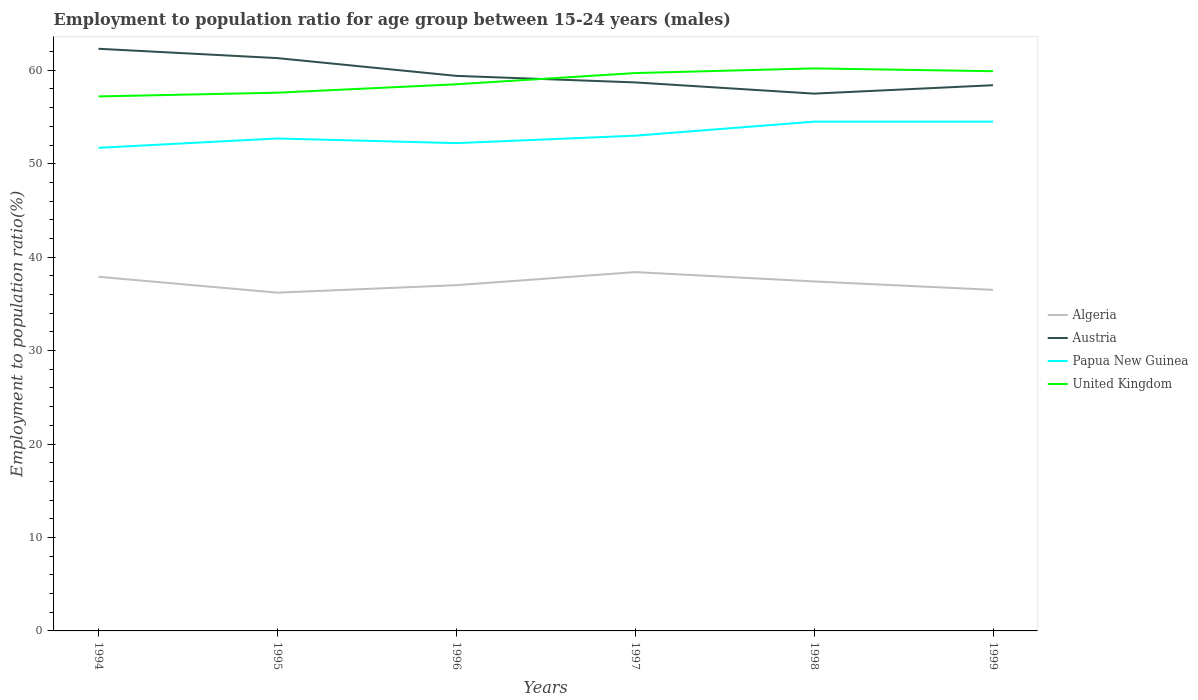How many different coloured lines are there?
Provide a short and direct response. 4. Is the number of lines equal to the number of legend labels?
Keep it short and to the point. Yes. Across all years, what is the maximum employment to population ratio in Papua New Guinea?
Ensure brevity in your answer.  51.7. What is the total employment to population ratio in Papua New Guinea in the graph?
Provide a succinct answer. -2.8. What is the difference between the highest and the second highest employment to population ratio in United Kingdom?
Make the answer very short. 3. Where does the legend appear in the graph?
Keep it short and to the point. Center right. How many legend labels are there?
Offer a terse response. 4. What is the title of the graph?
Provide a short and direct response. Employment to population ratio for age group between 15-24 years (males). Does "Upper middle income" appear as one of the legend labels in the graph?
Make the answer very short. No. What is the label or title of the Y-axis?
Give a very brief answer. Employment to population ratio(%). What is the Employment to population ratio(%) of Algeria in 1994?
Give a very brief answer. 37.9. What is the Employment to population ratio(%) in Austria in 1994?
Ensure brevity in your answer.  62.3. What is the Employment to population ratio(%) in Papua New Guinea in 1994?
Ensure brevity in your answer.  51.7. What is the Employment to population ratio(%) of United Kingdom in 1994?
Your response must be concise. 57.2. What is the Employment to population ratio(%) in Algeria in 1995?
Your answer should be very brief. 36.2. What is the Employment to population ratio(%) in Austria in 1995?
Offer a terse response. 61.3. What is the Employment to population ratio(%) in Papua New Guinea in 1995?
Give a very brief answer. 52.7. What is the Employment to population ratio(%) of United Kingdom in 1995?
Your response must be concise. 57.6. What is the Employment to population ratio(%) of Austria in 1996?
Keep it short and to the point. 59.4. What is the Employment to population ratio(%) in Papua New Guinea in 1996?
Offer a very short reply. 52.2. What is the Employment to population ratio(%) of United Kingdom in 1996?
Offer a terse response. 58.5. What is the Employment to population ratio(%) of Algeria in 1997?
Offer a very short reply. 38.4. What is the Employment to population ratio(%) of Austria in 1997?
Ensure brevity in your answer.  58.7. What is the Employment to population ratio(%) in Papua New Guinea in 1997?
Offer a terse response. 53. What is the Employment to population ratio(%) of United Kingdom in 1997?
Make the answer very short. 59.7. What is the Employment to population ratio(%) of Algeria in 1998?
Keep it short and to the point. 37.4. What is the Employment to population ratio(%) in Austria in 1998?
Provide a short and direct response. 57.5. What is the Employment to population ratio(%) in Papua New Guinea in 1998?
Your answer should be very brief. 54.5. What is the Employment to population ratio(%) in United Kingdom in 1998?
Your response must be concise. 60.2. What is the Employment to population ratio(%) in Algeria in 1999?
Offer a very short reply. 36.5. What is the Employment to population ratio(%) of Austria in 1999?
Make the answer very short. 58.4. What is the Employment to population ratio(%) of Papua New Guinea in 1999?
Provide a short and direct response. 54.5. What is the Employment to population ratio(%) of United Kingdom in 1999?
Make the answer very short. 59.9. Across all years, what is the maximum Employment to population ratio(%) in Algeria?
Make the answer very short. 38.4. Across all years, what is the maximum Employment to population ratio(%) in Austria?
Your answer should be compact. 62.3. Across all years, what is the maximum Employment to population ratio(%) in Papua New Guinea?
Ensure brevity in your answer.  54.5. Across all years, what is the maximum Employment to population ratio(%) of United Kingdom?
Your answer should be compact. 60.2. Across all years, what is the minimum Employment to population ratio(%) in Algeria?
Offer a very short reply. 36.2. Across all years, what is the minimum Employment to population ratio(%) of Austria?
Provide a succinct answer. 57.5. Across all years, what is the minimum Employment to population ratio(%) in Papua New Guinea?
Offer a terse response. 51.7. Across all years, what is the minimum Employment to population ratio(%) in United Kingdom?
Make the answer very short. 57.2. What is the total Employment to population ratio(%) of Algeria in the graph?
Your answer should be compact. 223.4. What is the total Employment to population ratio(%) of Austria in the graph?
Your response must be concise. 357.6. What is the total Employment to population ratio(%) in Papua New Guinea in the graph?
Give a very brief answer. 318.6. What is the total Employment to population ratio(%) of United Kingdom in the graph?
Offer a very short reply. 353.1. What is the difference between the Employment to population ratio(%) in Algeria in 1994 and that in 1995?
Provide a short and direct response. 1.7. What is the difference between the Employment to population ratio(%) of United Kingdom in 1994 and that in 1995?
Your answer should be very brief. -0.4. What is the difference between the Employment to population ratio(%) of Algeria in 1994 and that in 1996?
Ensure brevity in your answer.  0.9. What is the difference between the Employment to population ratio(%) in Austria in 1994 and that in 1996?
Offer a very short reply. 2.9. What is the difference between the Employment to population ratio(%) of United Kingdom in 1994 and that in 1996?
Provide a short and direct response. -1.3. What is the difference between the Employment to population ratio(%) of Algeria in 1994 and that in 1997?
Ensure brevity in your answer.  -0.5. What is the difference between the Employment to population ratio(%) in Austria in 1994 and that in 1997?
Your answer should be compact. 3.6. What is the difference between the Employment to population ratio(%) of Algeria in 1994 and that in 1998?
Keep it short and to the point. 0.5. What is the difference between the Employment to population ratio(%) of Papua New Guinea in 1994 and that in 1998?
Offer a very short reply. -2.8. What is the difference between the Employment to population ratio(%) in Algeria in 1995 and that in 1996?
Keep it short and to the point. -0.8. What is the difference between the Employment to population ratio(%) of Austria in 1995 and that in 1996?
Your response must be concise. 1.9. What is the difference between the Employment to population ratio(%) of Austria in 1995 and that in 1997?
Offer a terse response. 2.6. What is the difference between the Employment to population ratio(%) of Papua New Guinea in 1995 and that in 1997?
Offer a very short reply. -0.3. What is the difference between the Employment to population ratio(%) of United Kingdom in 1995 and that in 1997?
Provide a short and direct response. -2.1. What is the difference between the Employment to population ratio(%) in Austria in 1995 and that in 1998?
Provide a short and direct response. 3.8. What is the difference between the Employment to population ratio(%) in Algeria in 1995 and that in 1999?
Your answer should be very brief. -0.3. What is the difference between the Employment to population ratio(%) of United Kingdom in 1995 and that in 1999?
Make the answer very short. -2.3. What is the difference between the Employment to population ratio(%) of Austria in 1996 and that in 1997?
Ensure brevity in your answer.  0.7. What is the difference between the Employment to population ratio(%) of Algeria in 1996 and that in 1999?
Offer a terse response. 0.5. What is the difference between the Employment to population ratio(%) in Austria in 1997 and that in 1998?
Make the answer very short. 1.2. What is the difference between the Employment to population ratio(%) of Papua New Guinea in 1997 and that in 1998?
Provide a succinct answer. -1.5. What is the difference between the Employment to population ratio(%) of United Kingdom in 1997 and that in 1998?
Keep it short and to the point. -0.5. What is the difference between the Employment to population ratio(%) of Austria in 1997 and that in 1999?
Ensure brevity in your answer.  0.3. What is the difference between the Employment to population ratio(%) of United Kingdom in 1998 and that in 1999?
Offer a very short reply. 0.3. What is the difference between the Employment to population ratio(%) of Algeria in 1994 and the Employment to population ratio(%) of Austria in 1995?
Ensure brevity in your answer.  -23.4. What is the difference between the Employment to population ratio(%) of Algeria in 1994 and the Employment to population ratio(%) of Papua New Guinea in 1995?
Your response must be concise. -14.8. What is the difference between the Employment to population ratio(%) in Algeria in 1994 and the Employment to population ratio(%) in United Kingdom in 1995?
Your answer should be very brief. -19.7. What is the difference between the Employment to population ratio(%) of Austria in 1994 and the Employment to population ratio(%) of Papua New Guinea in 1995?
Offer a terse response. 9.6. What is the difference between the Employment to population ratio(%) of Algeria in 1994 and the Employment to population ratio(%) of Austria in 1996?
Your response must be concise. -21.5. What is the difference between the Employment to population ratio(%) of Algeria in 1994 and the Employment to population ratio(%) of Papua New Guinea in 1996?
Provide a succinct answer. -14.3. What is the difference between the Employment to population ratio(%) of Algeria in 1994 and the Employment to population ratio(%) of United Kingdom in 1996?
Your response must be concise. -20.6. What is the difference between the Employment to population ratio(%) in Austria in 1994 and the Employment to population ratio(%) in Papua New Guinea in 1996?
Provide a succinct answer. 10.1. What is the difference between the Employment to population ratio(%) of Algeria in 1994 and the Employment to population ratio(%) of Austria in 1997?
Your answer should be very brief. -20.8. What is the difference between the Employment to population ratio(%) of Algeria in 1994 and the Employment to population ratio(%) of Papua New Guinea in 1997?
Your answer should be very brief. -15.1. What is the difference between the Employment to population ratio(%) of Algeria in 1994 and the Employment to population ratio(%) of United Kingdom in 1997?
Offer a very short reply. -21.8. What is the difference between the Employment to population ratio(%) in Austria in 1994 and the Employment to population ratio(%) in United Kingdom in 1997?
Keep it short and to the point. 2.6. What is the difference between the Employment to population ratio(%) in Algeria in 1994 and the Employment to population ratio(%) in Austria in 1998?
Your response must be concise. -19.6. What is the difference between the Employment to population ratio(%) in Algeria in 1994 and the Employment to population ratio(%) in Papua New Guinea in 1998?
Offer a very short reply. -16.6. What is the difference between the Employment to population ratio(%) of Algeria in 1994 and the Employment to population ratio(%) of United Kingdom in 1998?
Your response must be concise. -22.3. What is the difference between the Employment to population ratio(%) in Papua New Guinea in 1994 and the Employment to population ratio(%) in United Kingdom in 1998?
Offer a very short reply. -8.5. What is the difference between the Employment to population ratio(%) of Algeria in 1994 and the Employment to population ratio(%) of Austria in 1999?
Make the answer very short. -20.5. What is the difference between the Employment to population ratio(%) of Algeria in 1994 and the Employment to population ratio(%) of Papua New Guinea in 1999?
Give a very brief answer. -16.6. What is the difference between the Employment to population ratio(%) in Algeria in 1995 and the Employment to population ratio(%) in Austria in 1996?
Provide a short and direct response. -23.2. What is the difference between the Employment to population ratio(%) of Algeria in 1995 and the Employment to population ratio(%) of Papua New Guinea in 1996?
Your response must be concise. -16. What is the difference between the Employment to population ratio(%) of Algeria in 1995 and the Employment to population ratio(%) of United Kingdom in 1996?
Provide a succinct answer. -22.3. What is the difference between the Employment to population ratio(%) in Papua New Guinea in 1995 and the Employment to population ratio(%) in United Kingdom in 1996?
Provide a short and direct response. -5.8. What is the difference between the Employment to population ratio(%) in Algeria in 1995 and the Employment to population ratio(%) in Austria in 1997?
Keep it short and to the point. -22.5. What is the difference between the Employment to population ratio(%) in Algeria in 1995 and the Employment to population ratio(%) in Papua New Guinea in 1997?
Ensure brevity in your answer.  -16.8. What is the difference between the Employment to population ratio(%) of Algeria in 1995 and the Employment to population ratio(%) of United Kingdom in 1997?
Provide a succinct answer. -23.5. What is the difference between the Employment to population ratio(%) of Austria in 1995 and the Employment to population ratio(%) of United Kingdom in 1997?
Give a very brief answer. 1.6. What is the difference between the Employment to population ratio(%) of Papua New Guinea in 1995 and the Employment to population ratio(%) of United Kingdom in 1997?
Your response must be concise. -7. What is the difference between the Employment to population ratio(%) of Algeria in 1995 and the Employment to population ratio(%) of Austria in 1998?
Offer a terse response. -21.3. What is the difference between the Employment to population ratio(%) in Algeria in 1995 and the Employment to population ratio(%) in Papua New Guinea in 1998?
Provide a succinct answer. -18.3. What is the difference between the Employment to population ratio(%) in Austria in 1995 and the Employment to population ratio(%) in Papua New Guinea in 1998?
Offer a terse response. 6.8. What is the difference between the Employment to population ratio(%) in Austria in 1995 and the Employment to population ratio(%) in United Kingdom in 1998?
Your response must be concise. 1.1. What is the difference between the Employment to population ratio(%) in Papua New Guinea in 1995 and the Employment to population ratio(%) in United Kingdom in 1998?
Your answer should be very brief. -7.5. What is the difference between the Employment to population ratio(%) of Algeria in 1995 and the Employment to population ratio(%) of Austria in 1999?
Make the answer very short. -22.2. What is the difference between the Employment to population ratio(%) in Algeria in 1995 and the Employment to population ratio(%) in Papua New Guinea in 1999?
Provide a succinct answer. -18.3. What is the difference between the Employment to population ratio(%) in Algeria in 1995 and the Employment to population ratio(%) in United Kingdom in 1999?
Make the answer very short. -23.7. What is the difference between the Employment to population ratio(%) of Algeria in 1996 and the Employment to population ratio(%) of Austria in 1997?
Give a very brief answer. -21.7. What is the difference between the Employment to population ratio(%) in Algeria in 1996 and the Employment to population ratio(%) in Papua New Guinea in 1997?
Your answer should be compact. -16. What is the difference between the Employment to population ratio(%) of Algeria in 1996 and the Employment to population ratio(%) of United Kingdom in 1997?
Ensure brevity in your answer.  -22.7. What is the difference between the Employment to population ratio(%) of Papua New Guinea in 1996 and the Employment to population ratio(%) of United Kingdom in 1997?
Your answer should be compact. -7.5. What is the difference between the Employment to population ratio(%) of Algeria in 1996 and the Employment to population ratio(%) of Austria in 1998?
Make the answer very short. -20.5. What is the difference between the Employment to population ratio(%) in Algeria in 1996 and the Employment to population ratio(%) in Papua New Guinea in 1998?
Provide a short and direct response. -17.5. What is the difference between the Employment to population ratio(%) in Algeria in 1996 and the Employment to population ratio(%) in United Kingdom in 1998?
Ensure brevity in your answer.  -23.2. What is the difference between the Employment to population ratio(%) of Austria in 1996 and the Employment to population ratio(%) of Papua New Guinea in 1998?
Your answer should be compact. 4.9. What is the difference between the Employment to population ratio(%) of Algeria in 1996 and the Employment to population ratio(%) of Austria in 1999?
Offer a very short reply. -21.4. What is the difference between the Employment to population ratio(%) of Algeria in 1996 and the Employment to population ratio(%) of Papua New Guinea in 1999?
Give a very brief answer. -17.5. What is the difference between the Employment to population ratio(%) in Algeria in 1996 and the Employment to population ratio(%) in United Kingdom in 1999?
Your answer should be very brief. -22.9. What is the difference between the Employment to population ratio(%) of Austria in 1996 and the Employment to population ratio(%) of Papua New Guinea in 1999?
Your response must be concise. 4.9. What is the difference between the Employment to population ratio(%) in Austria in 1996 and the Employment to population ratio(%) in United Kingdom in 1999?
Offer a very short reply. -0.5. What is the difference between the Employment to population ratio(%) of Algeria in 1997 and the Employment to population ratio(%) of Austria in 1998?
Your response must be concise. -19.1. What is the difference between the Employment to population ratio(%) in Algeria in 1997 and the Employment to population ratio(%) in Papua New Guinea in 1998?
Make the answer very short. -16.1. What is the difference between the Employment to population ratio(%) in Algeria in 1997 and the Employment to population ratio(%) in United Kingdom in 1998?
Your answer should be very brief. -21.8. What is the difference between the Employment to population ratio(%) in Papua New Guinea in 1997 and the Employment to population ratio(%) in United Kingdom in 1998?
Your answer should be compact. -7.2. What is the difference between the Employment to population ratio(%) of Algeria in 1997 and the Employment to population ratio(%) of Papua New Guinea in 1999?
Keep it short and to the point. -16.1. What is the difference between the Employment to population ratio(%) of Algeria in 1997 and the Employment to population ratio(%) of United Kingdom in 1999?
Ensure brevity in your answer.  -21.5. What is the difference between the Employment to population ratio(%) of Austria in 1997 and the Employment to population ratio(%) of Papua New Guinea in 1999?
Give a very brief answer. 4.2. What is the difference between the Employment to population ratio(%) in Austria in 1997 and the Employment to population ratio(%) in United Kingdom in 1999?
Your answer should be compact. -1.2. What is the difference between the Employment to population ratio(%) in Algeria in 1998 and the Employment to population ratio(%) in Papua New Guinea in 1999?
Provide a short and direct response. -17.1. What is the difference between the Employment to population ratio(%) in Algeria in 1998 and the Employment to population ratio(%) in United Kingdom in 1999?
Ensure brevity in your answer.  -22.5. What is the difference between the Employment to population ratio(%) of Austria in 1998 and the Employment to population ratio(%) of United Kingdom in 1999?
Keep it short and to the point. -2.4. What is the average Employment to population ratio(%) in Algeria per year?
Give a very brief answer. 37.23. What is the average Employment to population ratio(%) of Austria per year?
Your answer should be very brief. 59.6. What is the average Employment to population ratio(%) in Papua New Guinea per year?
Give a very brief answer. 53.1. What is the average Employment to population ratio(%) of United Kingdom per year?
Provide a short and direct response. 58.85. In the year 1994, what is the difference between the Employment to population ratio(%) of Algeria and Employment to population ratio(%) of Austria?
Offer a terse response. -24.4. In the year 1994, what is the difference between the Employment to population ratio(%) in Algeria and Employment to population ratio(%) in United Kingdom?
Your answer should be very brief. -19.3. In the year 1994, what is the difference between the Employment to population ratio(%) of Austria and Employment to population ratio(%) of United Kingdom?
Your answer should be compact. 5.1. In the year 1995, what is the difference between the Employment to population ratio(%) of Algeria and Employment to population ratio(%) of Austria?
Your answer should be compact. -25.1. In the year 1995, what is the difference between the Employment to population ratio(%) of Algeria and Employment to population ratio(%) of Papua New Guinea?
Ensure brevity in your answer.  -16.5. In the year 1995, what is the difference between the Employment to population ratio(%) of Algeria and Employment to population ratio(%) of United Kingdom?
Give a very brief answer. -21.4. In the year 1995, what is the difference between the Employment to population ratio(%) in Austria and Employment to population ratio(%) in United Kingdom?
Provide a succinct answer. 3.7. In the year 1996, what is the difference between the Employment to population ratio(%) of Algeria and Employment to population ratio(%) of Austria?
Your answer should be very brief. -22.4. In the year 1996, what is the difference between the Employment to population ratio(%) in Algeria and Employment to population ratio(%) in Papua New Guinea?
Ensure brevity in your answer.  -15.2. In the year 1996, what is the difference between the Employment to population ratio(%) of Algeria and Employment to population ratio(%) of United Kingdom?
Give a very brief answer. -21.5. In the year 1996, what is the difference between the Employment to population ratio(%) of Austria and Employment to population ratio(%) of United Kingdom?
Make the answer very short. 0.9. In the year 1997, what is the difference between the Employment to population ratio(%) of Algeria and Employment to population ratio(%) of Austria?
Your response must be concise. -20.3. In the year 1997, what is the difference between the Employment to population ratio(%) in Algeria and Employment to population ratio(%) in Papua New Guinea?
Make the answer very short. -14.6. In the year 1997, what is the difference between the Employment to population ratio(%) of Algeria and Employment to population ratio(%) of United Kingdom?
Keep it short and to the point. -21.3. In the year 1997, what is the difference between the Employment to population ratio(%) of Austria and Employment to population ratio(%) of United Kingdom?
Offer a terse response. -1. In the year 1997, what is the difference between the Employment to population ratio(%) in Papua New Guinea and Employment to population ratio(%) in United Kingdom?
Your response must be concise. -6.7. In the year 1998, what is the difference between the Employment to population ratio(%) of Algeria and Employment to population ratio(%) of Austria?
Ensure brevity in your answer.  -20.1. In the year 1998, what is the difference between the Employment to population ratio(%) in Algeria and Employment to population ratio(%) in Papua New Guinea?
Your answer should be very brief. -17.1. In the year 1998, what is the difference between the Employment to population ratio(%) of Algeria and Employment to population ratio(%) of United Kingdom?
Make the answer very short. -22.8. In the year 1998, what is the difference between the Employment to population ratio(%) of Austria and Employment to population ratio(%) of Papua New Guinea?
Your answer should be very brief. 3. In the year 1999, what is the difference between the Employment to population ratio(%) in Algeria and Employment to population ratio(%) in Austria?
Provide a short and direct response. -21.9. In the year 1999, what is the difference between the Employment to population ratio(%) in Algeria and Employment to population ratio(%) in United Kingdom?
Ensure brevity in your answer.  -23.4. What is the ratio of the Employment to population ratio(%) of Algeria in 1994 to that in 1995?
Make the answer very short. 1.05. What is the ratio of the Employment to population ratio(%) of Austria in 1994 to that in 1995?
Ensure brevity in your answer.  1.02. What is the ratio of the Employment to population ratio(%) of Algeria in 1994 to that in 1996?
Keep it short and to the point. 1.02. What is the ratio of the Employment to population ratio(%) in Austria in 1994 to that in 1996?
Give a very brief answer. 1.05. What is the ratio of the Employment to population ratio(%) of Papua New Guinea in 1994 to that in 1996?
Give a very brief answer. 0.99. What is the ratio of the Employment to population ratio(%) in United Kingdom in 1994 to that in 1996?
Your answer should be very brief. 0.98. What is the ratio of the Employment to population ratio(%) of Austria in 1994 to that in 1997?
Make the answer very short. 1.06. What is the ratio of the Employment to population ratio(%) of Papua New Guinea in 1994 to that in 1997?
Keep it short and to the point. 0.98. What is the ratio of the Employment to population ratio(%) in United Kingdom in 1994 to that in 1997?
Keep it short and to the point. 0.96. What is the ratio of the Employment to population ratio(%) of Algeria in 1994 to that in 1998?
Offer a terse response. 1.01. What is the ratio of the Employment to population ratio(%) in Austria in 1994 to that in 1998?
Keep it short and to the point. 1.08. What is the ratio of the Employment to population ratio(%) in Papua New Guinea in 1994 to that in 1998?
Provide a succinct answer. 0.95. What is the ratio of the Employment to population ratio(%) in United Kingdom in 1994 to that in 1998?
Your answer should be very brief. 0.95. What is the ratio of the Employment to population ratio(%) of Algeria in 1994 to that in 1999?
Ensure brevity in your answer.  1.04. What is the ratio of the Employment to population ratio(%) in Austria in 1994 to that in 1999?
Your answer should be compact. 1.07. What is the ratio of the Employment to population ratio(%) in Papua New Guinea in 1994 to that in 1999?
Your response must be concise. 0.95. What is the ratio of the Employment to population ratio(%) in United Kingdom in 1994 to that in 1999?
Provide a short and direct response. 0.95. What is the ratio of the Employment to population ratio(%) in Algeria in 1995 to that in 1996?
Make the answer very short. 0.98. What is the ratio of the Employment to population ratio(%) in Austria in 1995 to that in 1996?
Make the answer very short. 1.03. What is the ratio of the Employment to population ratio(%) of Papua New Guinea in 1995 to that in 1996?
Provide a succinct answer. 1.01. What is the ratio of the Employment to population ratio(%) of United Kingdom in 1995 to that in 1996?
Ensure brevity in your answer.  0.98. What is the ratio of the Employment to population ratio(%) of Algeria in 1995 to that in 1997?
Offer a very short reply. 0.94. What is the ratio of the Employment to population ratio(%) of Austria in 1995 to that in 1997?
Your answer should be compact. 1.04. What is the ratio of the Employment to population ratio(%) of Papua New Guinea in 1995 to that in 1997?
Offer a terse response. 0.99. What is the ratio of the Employment to population ratio(%) in United Kingdom in 1995 to that in 1997?
Offer a terse response. 0.96. What is the ratio of the Employment to population ratio(%) of Algeria in 1995 to that in 1998?
Your answer should be very brief. 0.97. What is the ratio of the Employment to population ratio(%) of Austria in 1995 to that in 1998?
Offer a very short reply. 1.07. What is the ratio of the Employment to population ratio(%) of United Kingdom in 1995 to that in 1998?
Offer a very short reply. 0.96. What is the ratio of the Employment to population ratio(%) in Algeria in 1995 to that in 1999?
Offer a terse response. 0.99. What is the ratio of the Employment to population ratio(%) of Austria in 1995 to that in 1999?
Your answer should be compact. 1.05. What is the ratio of the Employment to population ratio(%) in United Kingdom in 1995 to that in 1999?
Provide a short and direct response. 0.96. What is the ratio of the Employment to population ratio(%) in Algeria in 1996 to that in 1997?
Keep it short and to the point. 0.96. What is the ratio of the Employment to population ratio(%) of Austria in 1996 to that in 1997?
Offer a terse response. 1.01. What is the ratio of the Employment to population ratio(%) in Papua New Guinea in 1996 to that in 1997?
Offer a terse response. 0.98. What is the ratio of the Employment to population ratio(%) in United Kingdom in 1996 to that in 1997?
Your response must be concise. 0.98. What is the ratio of the Employment to population ratio(%) in Algeria in 1996 to that in 1998?
Offer a very short reply. 0.99. What is the ratio of the Employment to population ratio(%) in Austria in 1996 to that in 1998?
Give a very brief answer. 1.03. What is the ratio of the Employment to population ratio(%) of Papua New Guinea in 1996 to that in 1998?
Your answer should be very brief. 0.96. What is the ratio of the Employment to population ratio(%) of United Kingdom in 1996 to that in 1998?
Provide a short and direct response. 0.97. What is the ratio of the Employment to population ratio(%) of Algeria in 1996 to that in 1999?
Your response must be concise. 1.01. What is the ratio of the Employment to population ratio(%) in Austria in 1996 to that in 1999?
Make the answer very short. 1.02. What is the ratio of the Employment to population ratio(%) in Papua New Guinea in 1996 to that in 1999?
Give a very brief answer. 0.96. What is the ratio of the Employment to population ratio(%) of United Kingdom in 1996 to that in 1999?
Provide a short and direct response. 0.98. What is the ratio of the Employment to population ratio(%) in Algeria in 1997 to that in 1998?
Ensure brevity in your answer.  1.03. What is the ratio of the Employment to population ratio(%) in Austria in 1997 to that in 1998?
Offer a terse response. 1.02. What is the ratio of the Employment to population ratio(%) in Papua New Guinea in 1997 to that in 1998?
Your answer should be very brief. 0.97. What is the ratio of the Employment to population ratio(%) of United Kingdom in 1997 to that in 1998?
Ensure brevity in your answer.  0.99. What is the ratio of the Employment to population ratio(%) in Algeria in 1997 to that in 1999?
Your answer should be very brief. 1.05. What is the ratio of the Employment to population ratio(%) in Austria in 1997 to that in 1999?
Provide a succinct answer. 1.01. What is the ratio of the Employment to population ratio(%) in Papua New Guinea in 1997 to that in 1999?
Keep it short and to the point. 0.97. What is the ratio of the Employment to population ratio(%) in United Kingdom in 1997 to that in 1999?
Your answer should be compact. 1. What is the ratio of the Employment to population ratio(%) in Algeria in 1998 to that in 1999?
Keep it short and to the point. 1.02. What is the ratio of the Employment to population ratio(%) of Austria in 1998 to that in 1999?
Ensure brevity in your answer.  0.98. What is the ratio of the Employment to population ratio(%) of Papua New Guinea in 1998 to that in 1999?
Make the answer very short. 1. What is the difference between the highest and the second highest Employment to population ratio(%) of Algeria?
Provide a short and direct response. 0.5. What is the difference between the highest and the second highest Employment to population ratio(%) in Austria?
Ensure brevity in your answer.  1. What is the difference between the highest and the second highest Employment to population ratio(%) of United Kingdom?
Offer a very short reply. 0.3. What is the difference between the highest and the lowest Employment to population ratio(%) in Papua New Guinea?
Make the answer very short. 2.8. 